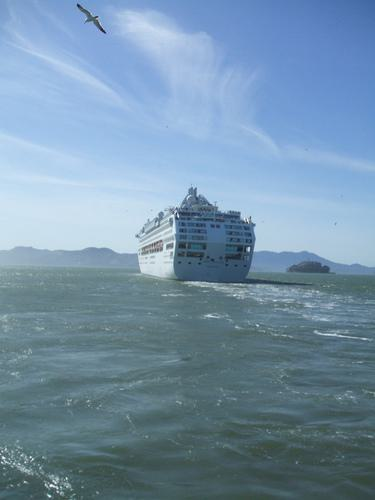Is there a boat in the image? Yes, there is a large cruise ship visible in the image, sailing across what appears to be a vast expanse of water under a clear blue sky. A seagull is flying overhead, which adds a sense of freedom and expansiveness to the scene. 